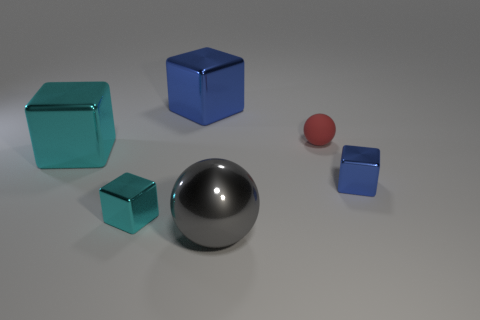Add 1 red cubes. How many objects exist? 7 Subtract all cubes. How many objects are left? 2 Add 2 cyan blocks. How many cyan blocks are left? 4 Add 5 large cyan cubes. How many large cyan cubes exist? 6 Subtract 0 cyan cylinders. How many objects are left? 6 Subtract all small shiny blocks. Subtract all large cyan metal blocks. How many objects are left? 3 